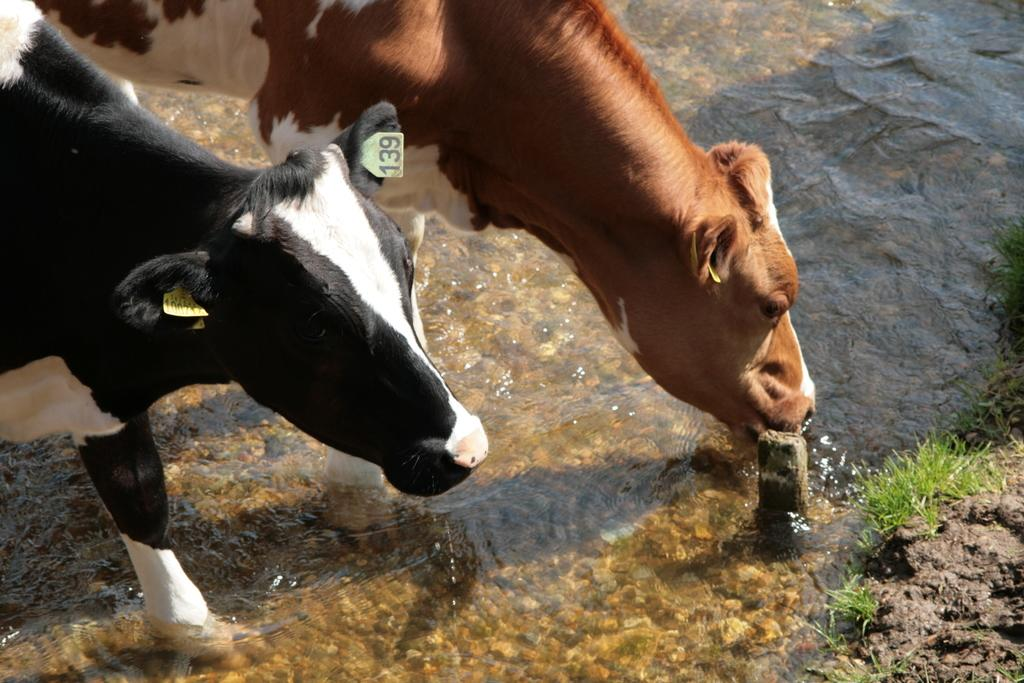What is the primary element visible in the image? There is water in the image. What type of vegetation can be seen in the image? There is grass in the image. What animals are present in the image? There are cows of different colors in the image. What type of fruit can be seen growing on the stage in the image? There is no stage or fruit present in the image; it features water, grass, and cows. 